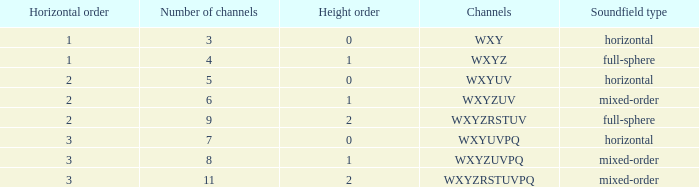If the channels is wxyzrstuvpq, what is the horizontal order? 3.0. Parse the table in full. {'header': ['Horizontal order', 'Number of channels', 'Height order', 'Channels', 'Soundfield type'], 'rows': [['1', '3', '0', 'WXY', 'horizontal'], ['1', '4', '1', 'WXYZ', 'full-sphere'], ['2', '5', '0', 'WXYUV', 'horizontal'], ['2', '6', '1', 'WXYZUV', 'mixed-order'], ['2', '9', '2', 'WXYZRSTUV', 'full-sphere'], ['3', '7', '0', 'WXYUVPQ', 'horizontal'], ['3', '8', '1', 'WXYZUVPQ', 'mixed-order'], ['3', '11', '2', 'WXYZRSTUVPQ', 'mixed-order']]} 